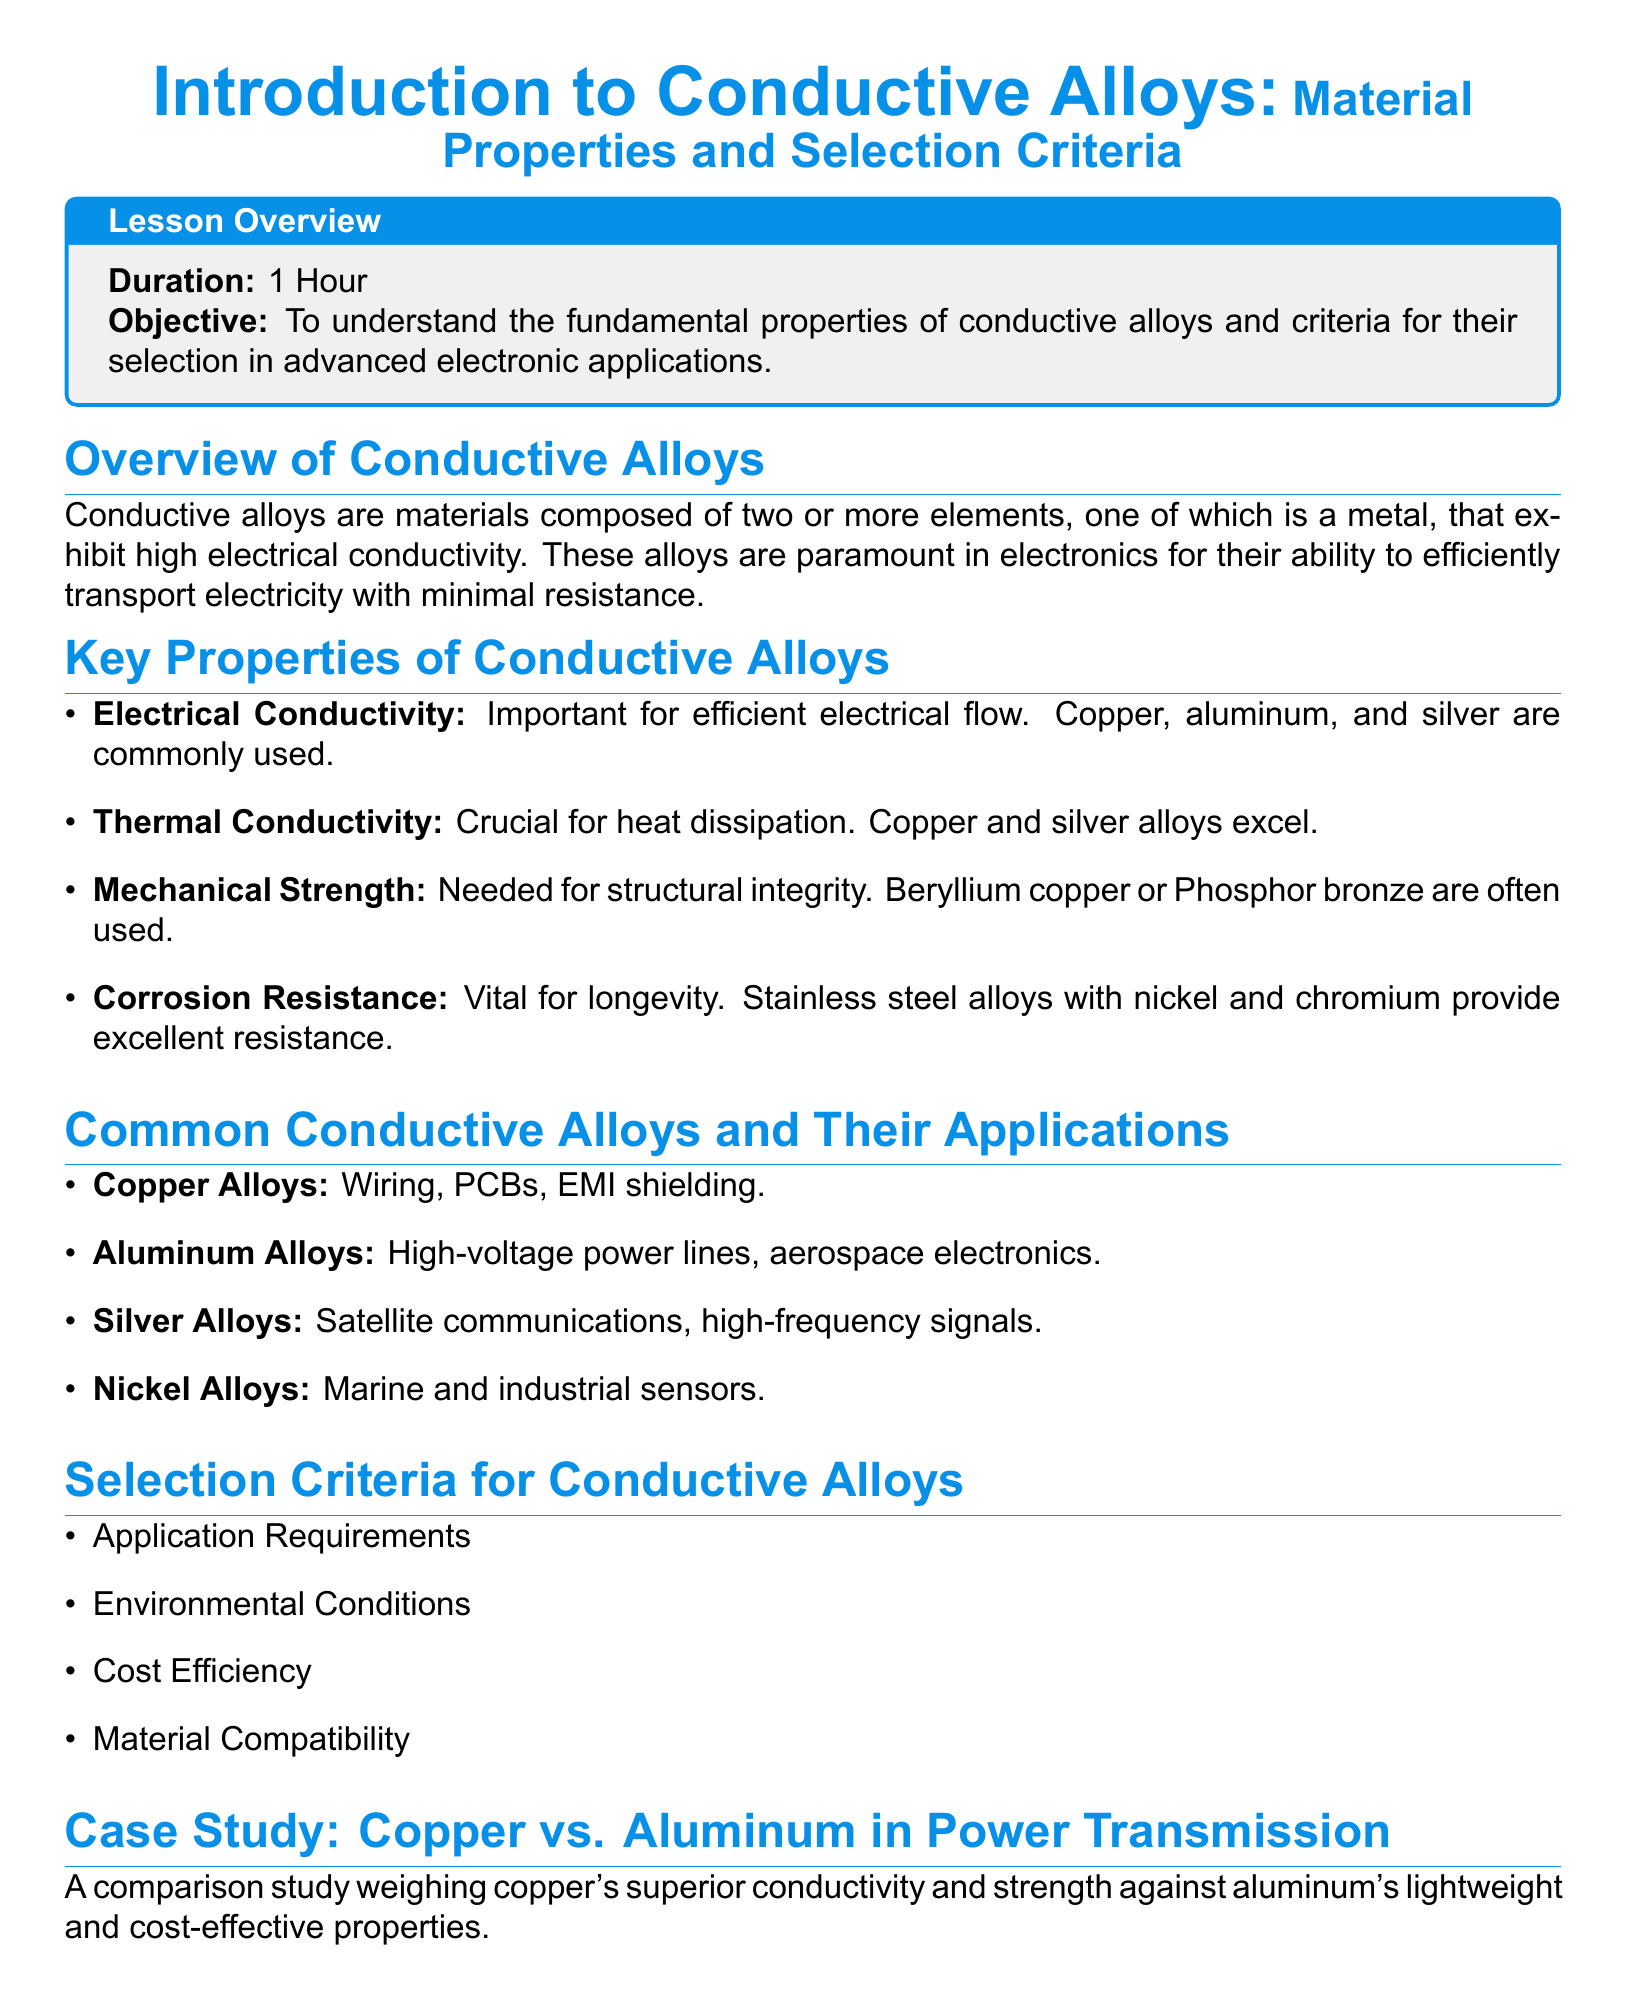What is the duration of the lesson? The duration of the lesson is specified in the lesson overview section.
Answer: 1 Hour What is the objective of the lesson? The objective is mentioned in the lesson overview section.
Answer: To understand the fundamental properties of conductive alloys and criteria for their selection in advanced electronic applications Which alloy is often used in high-voltage power lines? The document lists applications for different alloys in the common conductive alloys section.
Answer: Aluminum Alloys What is the main property considered for effective electrical flow? The key properties section outlines important characteristics, and this is one of them.
Answer: Electrical Conductivity Which alloy is mentioned for marine and industrial sensors? This information can be found in the common conductive alloys section.
Answer: Nickel Alloys What are the primary considerations for selecting a conductive alloy? The selection criteria section lists important factors to consider when choosing a conductive alloy.
Answer: Application Requirements What is highlighted as a recent advance in conductive alloys? The section on recent advances discusses current innovations related to alloys.
Answer: Innovations in nanostructured alloys Which metal is known for its excellent corrosion resistance? The key properties section specifies alloys that provide good corrosion resistance.
Answer: Stainless steel alloys with nickel and chromium 